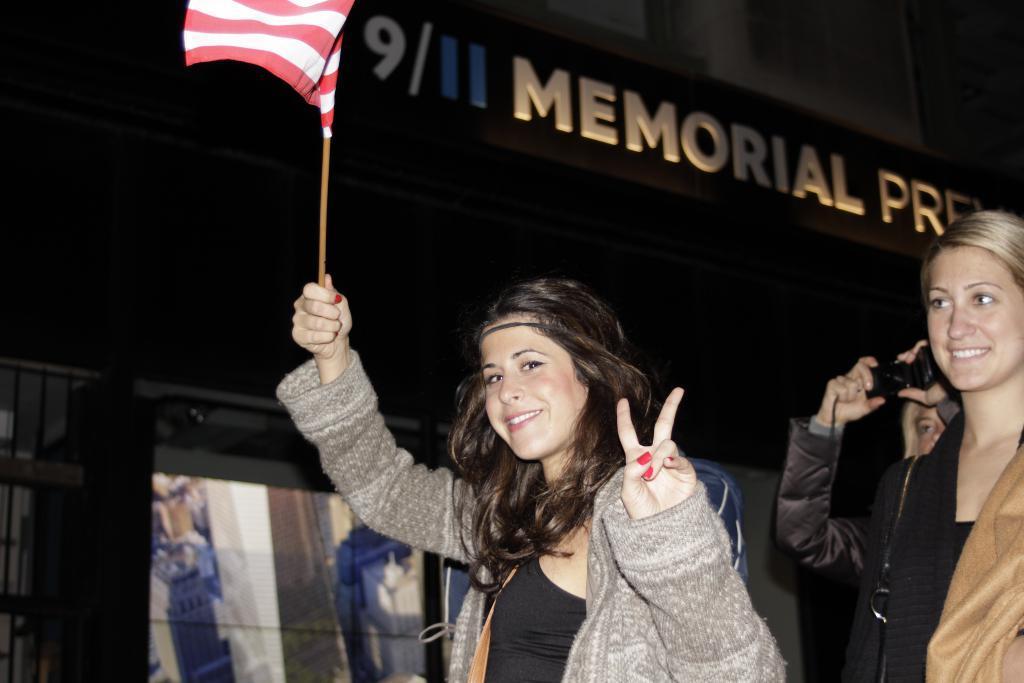In one or two sentences, can you explain what this image depicts? On the right side, there is a woman in a gray color jacket, smiling, holding a flag with a hand and showing a symbol with the other hand. Behind this person, there is another woman in a black color jacket, smiling. Behind this woman, there is a person holding a camera and capturing. In the background, there is a screen and there is a hoarding. 